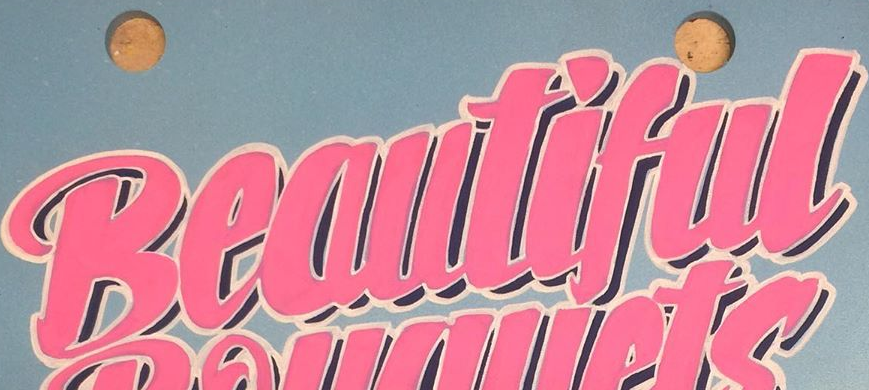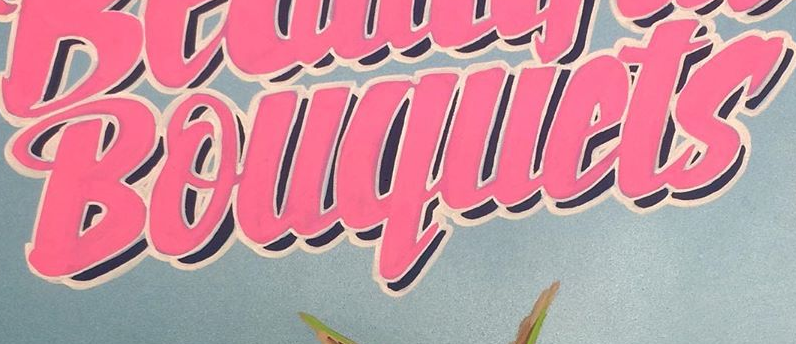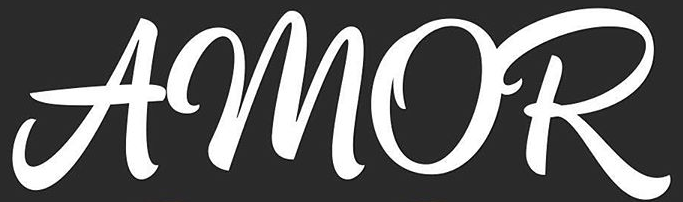What words can you see in these images in sequence, separated by a semicolon? Beautiful; Bouquets; AMOR 